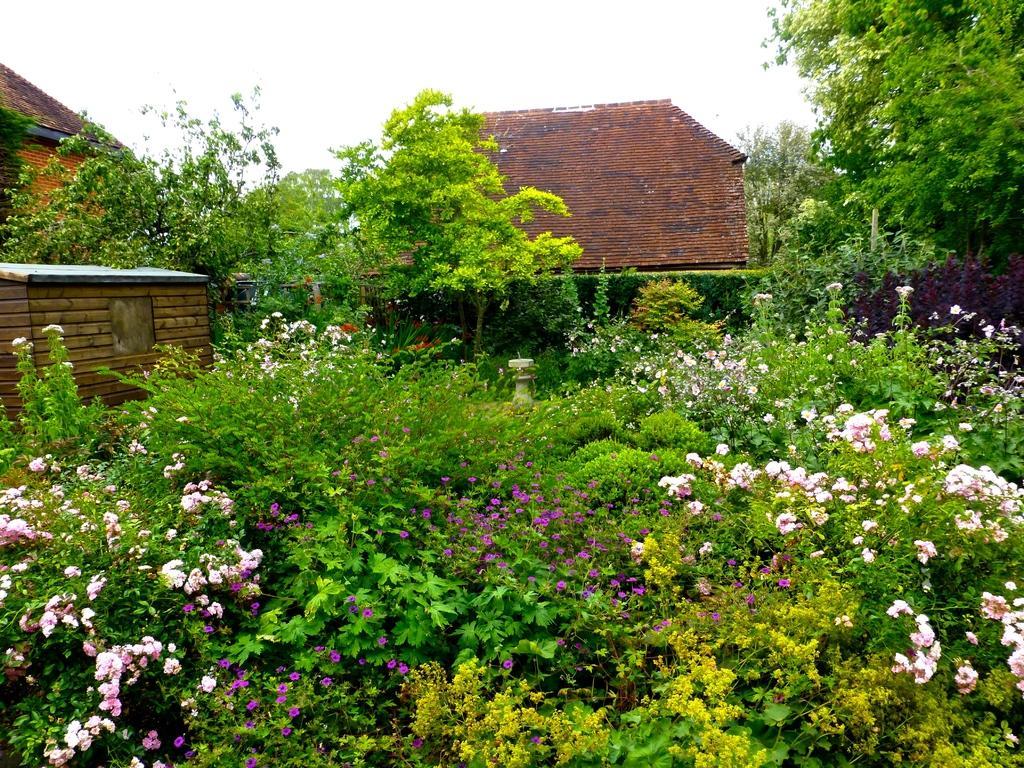Can you describe this image briefly? In Front portion of the picture we can see few flower plants. At the top we can see a sky. These are the houses. These are trees. 